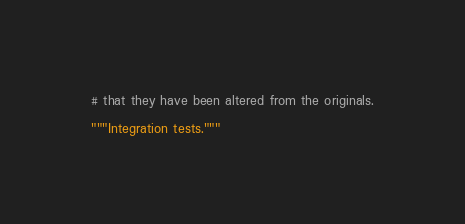<code> <loc_0><loc_0><loc_500><loc_500><_Python_># that they have been altered from the originals.

"""Integration tests."""
</code> 